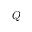Convert formula to latex. <formula><loc_0><loc_0><loc_500><loc_500>Q</formula> 